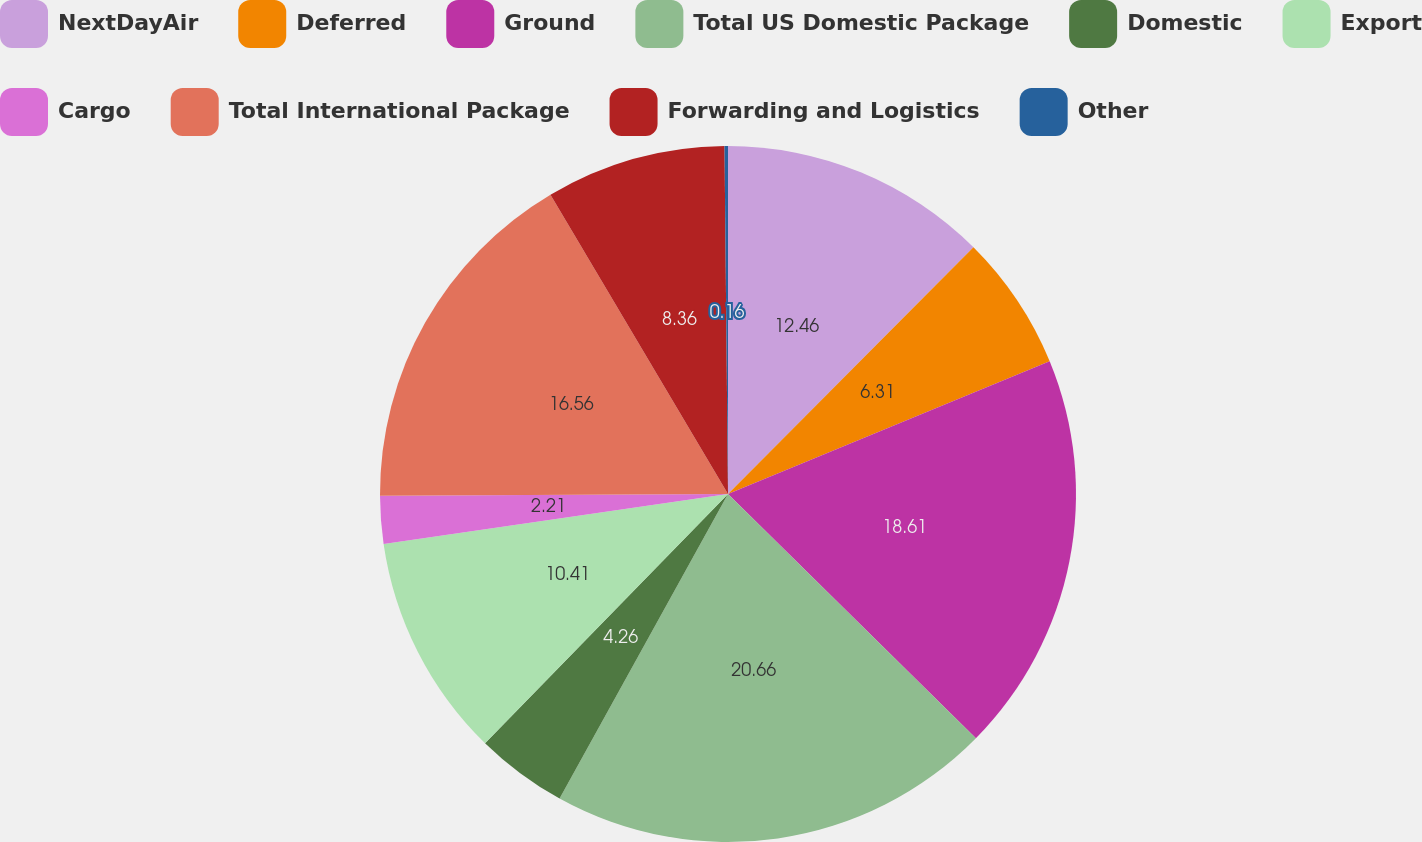Convert chart. <chart><loc_0><loc_0><loc_500><loc_500><pie_chart><fcel>NextDayAir<fcel>Deferred<fcel>Ground<fcel>Total US Domestic Package<fcel>Domestic<fcel>Export<fcel>Cargo<fcel>Total International Package<fcel>Forwarding and Logistics<fcel>Other<nl><fcel>12.46%<fcel>6.31%<fcel>18.61%<fcel>20.66%<fcel>4.26%<fcel>10.41%<fcel>2.21%<fcel>16.56%<fcel>8.36%<fcel>0.16%<nl></chart> 